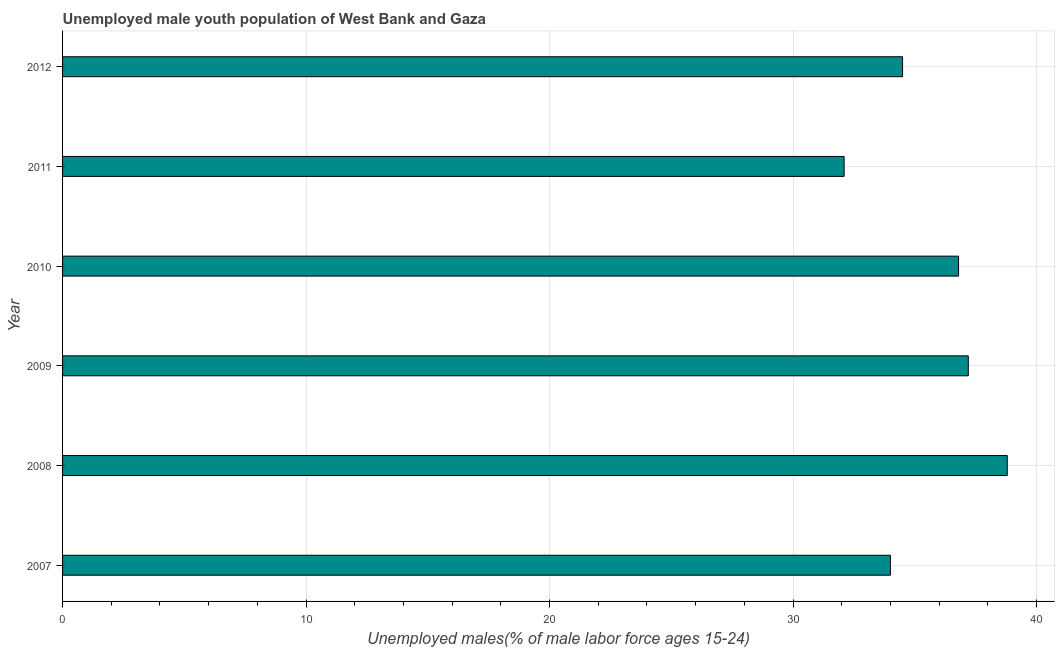Does the graph contain grids?
Give a very brief answer. Yes. What is the title of the graph?
Keep it short and to the point. Unemployed male youth population of West Bank and Gaza. What is the label or title of the X-axis?
Make the answer very short. Unemployed males(% of male labor force ages 15-24). What is the label or title of the Y-axis?
Provide a short and direct response. Year. What is the unemployed male youth in 2010?
Your response must be concise. 36.8. Across all years, what is the maximum unemployed male youth?
Provide a short and direct response. 38.8. Across all years, what is the minimum unemployed male youth?
Give a very brief answer. 32.1. In which year was the unemployed male youth minimum?
Offer a terse response. 2011. What is the sum of the unemployed male youth?
Make the answer very short. 213.4. What is the difference between the unemployed male youth in 2010 and 2012?
Keep it short and to the point. 2.3. What is the average unemployed male youth per year?
Keep it short and to the point. 35.57. What is the median unemployed male youth?
Make the answer very short. 35.65. Do a majority of the years between 2008 and 2010 (inclusive) have unemployed male youth greater than 36 %?
Offer a terse response. Yes. What is the ratio of the unemployed male youth in 2009 to that in 2011?
Your answer should be very brief. 1.16. Is the difference between the unemployed male youth in 2007 and 2012 greater than the difference between any two years?
Your answer should be very brief. No. What is the difference between the highest and the second highest unemployed male youth?
Keep it short and to the point. 1.6. Is the sum of the unemployed male youth in 2007 and 2008 greater than the maximum unemployed male youth across all years?
Offer a very short reply. Yes. What is the difference between the highest and the lowest unemployed male youth?
Make the answer very short. 6.7. In how many years, is the unemployed male youth greater than the average unemployed male youth taken over all years?
Provide a succinct answer. 3. What is the difference between two consecutive major ticks on the X-axis?
Your answer should be very brief. 10. What is the Unemployed males(% of male labor force ages 15-24) in 2008?
Your answer should be very brief. 38.8. What is the Unemployed males(% of male labor force ages 15-24) of 2009?
Your response must be concise. 37.2. What is the Unemployed males(% of male labor force ages 15-24) of 2010?
Give a very brief answer. 36.8. What is the Unemployed males(% of male labor force ages 15-24) in 2011?
Your answer should be very brief. 32.1. What is the Unemployed males(% of male labor force ages 15-24) of 2012?
Give a very brief answer. 34.5. What is the difference between the Unemployed males(% of male labor force ages 15-24) in 2007 and 2009?
Offer a very short reply. -3.2. What is the difference between the Unemployed males(% of male labor force ages 15-24) in 2007 and 2010?
Offer a very short reply. -2.8. What is the difference between the Unemployed males(% of male labor force ages 15-24) in 2007 and 2011?
Keep it short and to the point. 1.9. What is the difference between the Unemployed males(% of male labor force ages 15-24) in 2008 and 2009?
Offer a terse response. 1.6. What is the difference between the Unemployed males(% of male labor force ages 15-24) in 2008 and 2010?
Make the answer very short. 2. What is the difference between the Unemployed males(% of male labor force ages 15-24) in 2008 and 2011?
Offer a terse response. 6.7. What is the difference between the Unemployed males(% of male labor force ages 15-24) in 2009 and 2010?
Make the answer very short. 0.4. What is the difference between the Unemployed males(% of male labor force ages 15-24) in 2009 and 2011?
Your answer should be very brief. 5.1. What is the difference between the Unemployed males(% of male labor force ages 15-24) in 2010 and 2012?
Provide a short and direct response. 2.3. What is the difference between the Unemployed males(% of male labor force ages 15-24) in 2011 and 2012?
Offer a very short reply. -2.4. What is the ratio of the Unemployed males(% of male labor force ages 15-24) in 2007 to that in 2008?
Provide a short and direct response. 0.88. What is the ratio of the Unemployed males(% of male labor force ages 15-24) in 2007 to that in 2009?
Offer a terse response. 0.91. What is the ratio of the Unemployed males(% of male labor force ages 15-24) in 2007 to that in 2010?
Provide a succinct answer. 0.92. What is the ratio of the Unemployed males(% of male labor force ages 15-24) in 2007 to that in 2011?
Ensure brevity in your answer.  1.06. What is the ratio of the Unemployed males(% of male labor force ages 15-24) in 2007 to that in 2012?
Offer a very short reply. 0.99. What is the ratio of the Unemployed males(% of male labor force ages 15-24) in 2008 to that in 2009?
Offer a terse response. 1.04. What is the ratio of the Unemployed males(% of male labor force ages 15-24) in 2008 to that in 2010?
Offer a very short reply. 1.05. What is the ratio of the Unemployed males(% of male labor force ages 15-24) in 2008 to that in 2011?
Make the answer very short. 1.21. What is the ratio of the Unemployed males(% of male labor force ages 15-24) in 2009 to that in 2011?
Make the answer very short. 1.16. What is the ratio of the Unemployed males(% of male labor force ages 15-24) in 2009 to that in 2012?
Your answer should be compact. 1.08. What is the ratio of the Unemployed males(% of male labor force ages 15-24) in 2010 to that in 2011?
Your answer should be very brief. 1.15. What is the ratio of the Unemployed males(% of male labor force ages 15-24) in 2010 to that in 2012?
Provide a short and direct response. 1.07. What is the ratio of the Unemployed males(% of male labor force ages 15-24) in 2011 to that in 2012?
Give a very brief answer. 0.93. 